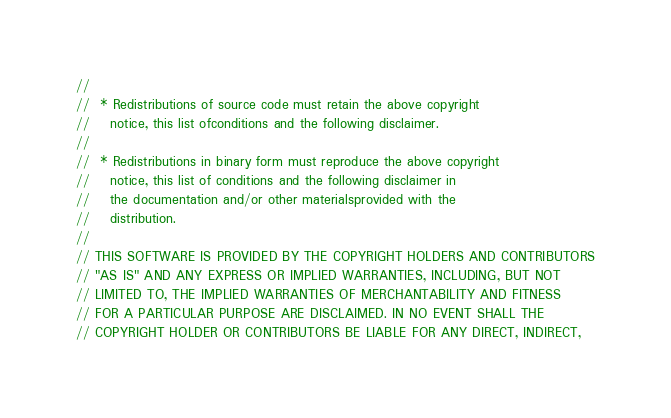Convert code to text. <code><loc_0><loc_0><loc_500><loc_500><_C_>//
//  * Redistributions of source code must retain the above copyright
//    notice, this list ofconditions and the following disclaimer.
//
//  * Redistributions in binary form must reproduce the above copyright
//    notice, this list of conditions and the following disclaimer in
//    the documentation and/or other materialsprovided with the
//    distribution.
//
// THIS SOFTWARE IS PROVIDED BY THE COPYRIGHT HOLDERS AND CONTRIBUTORS
// "AS IS" AND ANY EXPRESS OR IMPLIED WARRANTIES, INCLUDING, BUT NOT
// LIMITED TO, THE IMPLIED WARRANTIES OF MERCHANTABILITY AND FITNESS
// FOR A PARTICULAR PURPOSE ARE DISCLAIMED. IN NO EVENT SHALL THE
// COPYRIGHT HOLDER OR CONTRIBUTORS BE LIABLE FOR ANY DIRECT, INDIRECT,</code> 